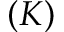<formula> <loc_0><loc_0><loc_500><loc_500>( K )</formula> 